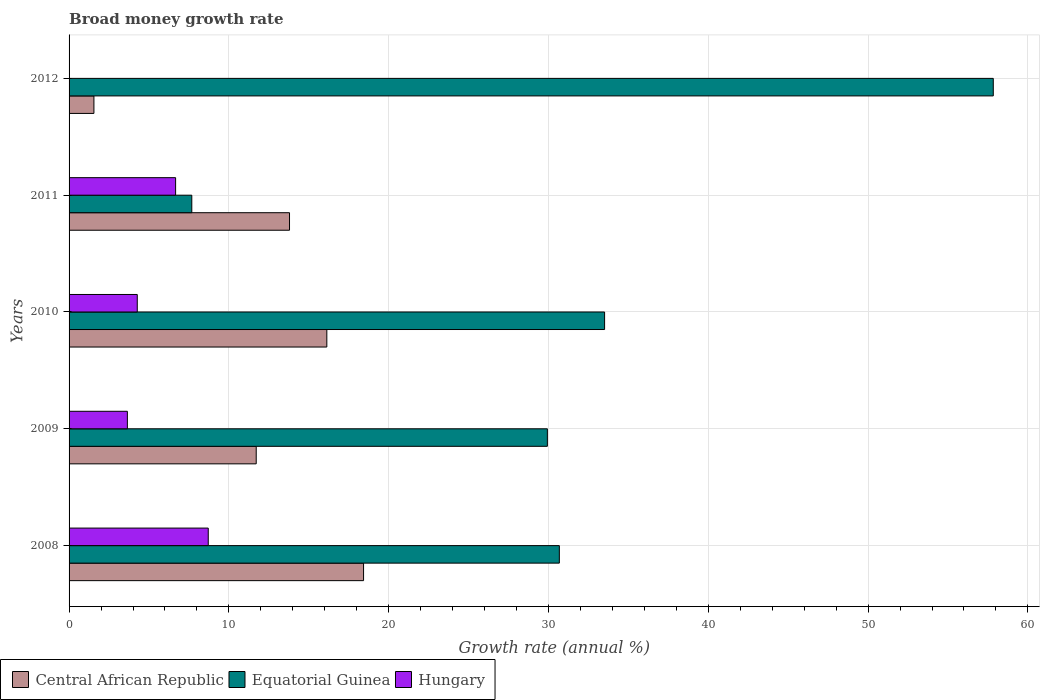In how many cases, is the number of bars for a given year not equal to the number of legend labels?
Offer a very short reply. 1. What is the growth rate in Hungary in 2009?
Provide a short and direct response. 3.65. Across all years, what is the maximum growth rate in Central African Republic?
Provide a short and direct response. 18.43. Across all years, what is the minimum growth rate in Equatorial Guinea?
Your answer should be very brief. 7.68. What is the total growth rate in Hungary in the graph?
Offer a terse response. 23.29. What is the difference between the growth rate in Central African Republic in 2010 and that in 2012?
Make the answer very short. 14.57. What is the difference between the growth rate in Central African Republic in 2010 and the growth rate in Equatorial Guinea in 2009?
Your answer should be very brief. -13.8. What is the average growth rate in Hungary per year?
Keep it short and to the point. 4.66. In the year 2011, what is the difference between the growth rate in Hungary and growth rate in Central African Republic?
Offer a terse response. -7.13. What is the ratio of the growth rate in Hungary in 2008 to that in 2010?
Provide a short and direct response. 2.04. Is the growth rate in Central African Republic in 2010 less than that in 2012?
Your response must be concise. No. What is the difference between the highest and the second highest growth rate in Hungary?
Your answer should be compact. 2.04. What is the difference between the highest and the lowest growth rate in Central African Republic?
Your answer should be compact. 16.87. In how many years, is the growth rate in Central African Republic greater than the average growth rate in Central African Republic taken over all years?
Make the answer very short. 3. Is the sum of the growth rate in Central African Republic in 2008 and 2012 greater than the maximum growth rate in Equatorial Guinea across all years?
Make the answer very short. No. How many bars are there?
Offer a very short reply. 14. Are all the bars in the graph horizontal?
Ensure brevity in your answer.  Yes. Where does the legend appear in the graph?
Provide a succinct answer. Bottom left. How many legend labels are there?
Your response must be concise. 3. What is the title of the graph?
Make the answer very short. Broad money growth rate. What is the label or title of the X-axis?
Your answer should be very brief. Growth rate (annual %). What is the label or title of the Y-axis?
Give a very brief answer. Years. What is the Growth rate (annual %) in Central African Republic in 2008?
Provide a succinct answer. 18.43. What is the Growth rate (annual %) in Equatorial Guinea in 2008?
Your answer should be very brief. 30.68. What is the Growth rate (annual %) of Hungary in 2008?
Provide a short and direct response. 8.71. What is the Growth rate (annual %) in Central African Republic in 2009?
Offer a terse response. 11.71. What is the Growth rate (annual %) of Equatorial Guinea in 2009?
Your answer should be compact. 29.93. What is the Growth rate (annual %) of Hungary in 2009?
Make the answer very short. 3.65. What is the Growth rate (annual %) of Central African Republic in 2010?
Give a very brief answer. 16.13. What is the Growth rate (annual %) in Equatorial Guinea in 2010?
Provide a succinct answer. 33.51. What is the Growth rate (annual %) of Hungary in 2010?
Offer a terse response. 4.27. What is the Growth rate (annual %) in Central African Republic in 2011?
Make the answer very short. 13.79. What is the Growth rate (annual %) of Equatorial Guinea in 2011?
Ensure brevity in your answer.  7.68. What is the Growth rate (annual %) in Hungary in 2011?
Give a very brief answer. 6.67. What is the Growth rate (annual %) in Central African Republic in 2012?
Provide a short and direct response. 1.56. What is the Growth rate (annual %) in Equatorial Guinea in 2012?
Your response must be concise. 57.83. What is the Growth rate (annual %) in Hungary in 2012?
Offer a very short reply. 0. Across all years, what is the maximum Growth rate (annual %) of Central African Republic?
Give a very brief answer. 18.43. Across all years, what is the maximum Growth rate (annual %) of Equatorial Guinea?
Keep it short and to the point. 57.83. Across all years, what is the maximum Growth rate (annual %) of Hungary?
Your answer should be very brief. 8.71. Across all years, what is the minimum Growth rate (annual %) in Central African Republic?
Provide a succinct answer. 1.56. Across all years, what is the minimum Growth rate (annual %) in Equatorial Guinea?
Ensure brevity in your answer.  7.68. Across all years, what is the minimum Growth rate (annual %) of Hungary?
Make the answer very short. 0. What is the total Growth rate (annual %) in Central African Republic in the graph?
Ensure brevity in your answer.  61.62. What is the total Growth rate (annual %) of Equatorial Guinea in the graph?
Your response must be concise. 159.63. What is the total Growth rate (annual %) in Hungary in the graph?
Your answer should be compact. 23.29. What is the difference between the Growth rate (annual %) in Central African Republic in 2008 and that in 2009?
Provide a succinct answer. 6.72. What is the difference between the Growth rate (annual %) in Equatorial Guinea in 2008 and that in 2009?
Offer a very short reply. 0.75. What is the difference between the Growth rate (annual %) in Hungary in 2008 and that in 2009?
Ensure brevity in your answer.  5.06. What is the difference between the Growth rate (annual %) of Central African Republic in 2008 and that in 2010?
Give a very brief answer. 2.3. What is the difference between the Growth rate (annual %) of Equatorial Guinea in 2008 and that in 2010?
Make the answer very short. -2.83. What is the difference between the Growth rate (annual %) in Hungary in 2008 and that in 2010?
Provide a succinct answer. 4.44. What is the difference between the Growth rate (annual %) in Central African Republic in 2008 and that in 2011?
Your answer should be very brief. 4.63. What is the difference between the Growth rate (annual %) in Equatorial Guinea in 2008 and that in 2011?
Offer a very short reply. 23. What is the difference between the Growth rate (annual %) of Hungary in 2008 and that in 2011?
Provide a succinct answer. 2.04. What is the difference between the Growth rate (annual %) in Central African Republic in 2008 and that in 2012?
Ensure brevity in your answer.  16.87. What is the difference between the Growth rate (annual %) of Equatorial Guinea in 2008 and that in 2012?
Your response must be concise. -27.15. What is the difference between the Growth rate (annual %) of Central African Republic in 2009 and that in 2010?
Make the answer very short. -4.42. What is the difference between the Growth rate (annual %) in Equatorial Guinea in 2009 and that in 2010?
Offer a very short reply. -3.58. What is the difference between the Growth rate (annual %) in Hungary in 2009 and that in 2010?
Your answer should be compact. -0.62. What is the difference between the Growth rate (annual %) in Central African Republic in 2009 and that in 2011?
Provide a short and direct response. -2.08. What is the difference between the Growth rate (annual %) in Equatorial Guinea in 2009 and that in 2011?
Your answer should be very brief. 22.25. What is the difference between the Growth rate (annual %) in Hungary in 2009 and that in 2011?
Offer a terse response. -3.02. What is the difference between the Growth rate (annual %) of Central African Republic in 2009 and that in 2012?
Ensure brevity in your answer.  10.16. What is the difference between the Growth rate (annual %) in Equatorial Guinea in 2009 and that in 2012?
Your answer should be very brief. -27.9. What is the difference between the Growth rate (annual %) in Central African Republic in 2010 and that in 2011?
Give a very brief answer. 2.33. What is the difference between the Growth rate (annual %) of Equatorial Guinea in 2010 and that in 2011?
Offer a terse response. 25.83. What is the difference between the Growth rate (annual %) in Hungary in 2010 and that in 2011?
Offer a very short reply. -2.4. What is the difference between the Growth rate (annual %) of Central African Republic in 2010 and that in 2012?
Provide a succinct answer. 14.57. What is the difference between the Growth rate (annual %) in Equatorial Guinea in 2010 and that in 2012?
Keep it short and to the point. -24.32. What is the difference between the Growth rate (annual %) of Central African Republic in 2011 and that in 2012?
Your answer should be very brief. 12.24. What is the difference between the Growth rate (annual %) in Equatorial Guinea in 2011 and that in 2012?
Provide a succinct answer. -50.15. What is the difference between the Growth rate (annual %) of Central African Republic in 2008 and the Growth rate (annual %) of Equatorial Guinea in 2009?
Offer a terse response. -11.5. What is the difference between the Growth rate (annual %) in Central African Republic in 2008 and the Growth rate (annual %) in Hungary in 2009?
Ensure brevity in your answer.  14.78. What is the difference between the Growth rate (annual %) in Equatorial Guinea in 2008 and the Growth rate (annual %) in Hungary in 2009?
Ensure brevity in your answer.  27.03. What is the difference between the Growth rate (annual %) in Central African Republic in 2008 and the Growth rate (annual %) in Equatorial Guinea in 2010?
Offer a very short reply. -15.08. What is the difference between the Growth rate (annual %) of Central African Republic in 2008 and the Growth rate (annual %) of Hungary in 2010?
Provide a succinct answer. 14.16. What is the difference between the Growth rate (annual %) of Equatorial Guinea in 2008 and the Growth rate (annual %) of Hungary in 2010?
Make the answer very short. 26.41. What is the difference between the Growth rate (annual %) in Central African Republic in 2008 and the Growth rate (annual %) in Equatorial Guinea in 2011?
Offer a very short reply. 10.75. What is the difference between the Growth rate (annual %) of Central African Republic in 2008 and the Growth rate (annual %) of Hungary in 2011?
Ensure brevity in your answer.  11.76. What is the difference between the Growth rate (annual %) of Equatorial Guinea in 2008 and the Growth rate (annual %) of Hungary in 2011?
Offer a terse response. 24.01. What is the difference between the Growth rate (annual %) of Central African Republic in 2008 and the Growth rate (annual %) of Equatorial Guinea in 2012?
Offer a very short reply. -39.41. What is the difference between the Growth rate (annual %) in Central African Republic in 2009 and the Growth rate (annual %) in Equatorial Guinea in 2010?
Your answer should be compact. -21.8. What is the difference between the Growth rate (annual %) in Central African Republic in 2009 and the Growth rate (annual %) in Hungary in 2010?
Offer a very short reply. 7.44. What is the difference between the Growth rate (annual %) in Equatorial Guinea in 2009 and the Growth rate (annual %) in Hungary in 2010?
Offer a very short reply. 25.66. What is the difference between the Growth rate (annual %) of Central African Republic in 2009 and the Growth rate (annual %) of Equatorial Guinea in 2011?
Offer a terse response. 4.03. What is the difference between the Growth rate (annual %) of Central African Republic in 2009 and the Growth rate (annual %) of Hungary in 2011?
Ensure brevity in your answer.  5.04. What is the difference between the Growth rate (annual %) in Equatorial Guinea in 2009 and the Growth rate (annual %) in Hungary in 2011?
Ensure brevity in your answer.  23.26. What is the difference between the Growth rate (annual %) of Central African Republic in 2009 and the Growth rate (annual %) of Equatorial Guinea in 2012?
Provide a succinct answer. -46.12. What is the difference between the Growth rate (annual %) of Central African Republic in 2010 and the Growth rate (annual %) of Equatorial Guinea in 2011?
Keep it short and to the point. 8.45. What is the difference between the Growth rate (annual %) of Central African Republic in 2010 and the Growth rate (annual %) of Hungary in 2011?
Provide a short and direct response. 9.46. What is the difference between the Growth rate (annual %) of Equatorial Guinea in 2010 and the Growth rate (annual %) of Hungary in 2011?
Ensure brevity in your answer.  26.84. What is the difference between the Growth rate (annual %) of Central African Republic in 2010 and the Growth rate (annual %) of Equatorial Guinea in 2012?
Your answer should be compact. -41.7. What is the difference between the Growth rate (annual %) in Central African Republic in 2011 and the Growth rate (annual %) in Equatorial Guinea in 2012?
Your response must be concise. -44.04. What is the average Growth rate (annual %) in Central African Republic per year?
Your response must be concise. 12.32. What is the average Growth rate (annual %) of Equatorial Guinea per year?
Your response must be concise. 31.93. What is the average Growth rate (annual %) in Hungary per year?
Give a very brief answer. 4.66. In the year 2008, what is the difference between the Growth rate (annual %) in Central African Republic and Growth rate (annual %) in Equatorial Guinea?
Keep it short and to the point. -12.25. In the year 2008, what is the difference between the Growth rate (annual %) of Central African Republic and Growth rate (annual %) of Hungary?
Provide a short and direct response. 9.72. In the year 2008, what is the difference between the Growth rate (annual %) of Equatorial Guinea and Growth rate (annual %) of Hungary?
Give a very brief answer. 21.97. In the year 2009, what is the difference between the Growth rate (annual %) in Central African Republic and Growth rate (annual %) in Equatorial Guinea?
Provide a short and direct response. -18.22. In the year 2009, what is the difference between the Growth rate (annual %) in Central African Republic and Growth rate (annual %) in Hungary?
Offer a very short reply. 8.06. In the year 2009, what is the difference between the Growth rate (annual %) in Equatorial Guinea and Growth rate (annual %) in Hungary?
Provide a short and direct response. 26.28. In the year 2010, what is the difference between the Growth rate (annual %) in Central African Republic and Growth rate (annual %) in Equatorial Guinea?
Your response must be concise. -17.38. In the year 2010, what is the difference between the Growth rate (annual %) of Central African Republic and Growth rate (annual %) of Hungary?
Keep it short and to the point. 11.86. In the year 2010, what is the difference between the Growth rate (annual %) of Equatorial Guinea and Growth rate (annual %) of Hungary?
Make the answer very short. 29.24. In the year 2011, what is the difference between the Growth rate (annual %) of Central African Republic and Growth rate (annual %) of Equatorial Guinea?
Provide a short and direct response. 6.11. In the year 2011, what is the difference between the Growth rate (annual %) in Central African Republic and Growth rate (annual %) in Hungary?
Your answer should be compact. 7.13. In the year 2011, what is the difference between the Growth rate (annual %) in Equatorial Guinea and Growth rate (annual %) in Hungary?
Ensure brevity in your answer.  1.01. In the year 2012, what is the difference between the Growth rate (annual %) of Central African Republic and Growth rate (annual %) of Equatorial Guinea?
Offer a terse response. -56.28. What is the ratio of the Growth rate (annual %) in Central African Republic in 2008 to that in 2009?
Provide a short and direct response. 1.57. What is the ratio of the Growth rate (annual %) in Hungary in 2008 to that in 2009?
Offer a very short reply. 2.39. What is the ratio of the Growth rate (annual %) of Central African Republic in 2008 to that in 2010?
Your answer should be compact. 1.14. What is the ratio of the Growth rate (annual %) in Equatorial Guinea in 2008 to that in 2010?
Keep it short and to the point. 0.92. What is the ratio of the Growth rate (annual %) of Hungary in 2008 to that in 2010?
Your response must be concise. 2.04. What is the ratio of the Growth rate (annual %) of Central African Republic in 2008 to that in 2011?
Give a very brief answer. 1.34. What is the ratio of the Growth rate (annual %) in Equatorial Guinea in 2008 to that in 2011?
Offer a very short reply. 3.99. What is the ratio of the Growth rate (annual %) in Hungary in 2008 to that in 2011?
Your answer should be compact. 1.31. What is the ratio of the Growth rate (annual %) of Central African Republic in 2008 to that in 2012?
Offer a very short reply. 11.85. What is the ratio of the Growth rate (annual %) in Equatorial Guinea in 2008 to that in 2012?
Provide a short and direct response. 0.53. What is the ratio of the Growth rate (annual %) in Central African Republic in 2009 to that in 2010?
Keep it short and to the point. 0.73. What is the ratio of the Growth rate (annual %) of Equatorial Guinea in 2009 to that in 2010?
Give a very brief answer. 0.89. What is the ratio of the Growth rate (annual %) in Hungary in 2009 to that in 2010?
Your answer should be compact. 0.85. What is the ratio of the Growth rate (annual %) in Central African Republic in 2009 to that in 2011?
Ensure brevity in your answer.  0.85. What is the ratio of the Growth rate (annual %) of Equatorial Guinea in 2009 to that in 2011?
Give a very brief answer. 3.9. What is the ratio of the Growth rate (annual %) in Hungary in 2009 to that in 2011?
Ensure brevity in your answer.  0.55. What is the ratio of the Growth rate (annual %) of Central African Republic in 2009 to that in 2012?
Give a very brief answer. 7.53. What is the ratio of the Growth rate (annual %) of Equatorial Guinea in 2009 to that in 2012?
Ensure brevity in your answer.  0.52. What is the ratio of the Growth rate (annual %) in Central African Republic in 2010 to that in 2011?
Your answer should be very brief. 1.17. What is the ratio of the Growth rate (annual %) in Equatorial Guinea in 2010 to that in 2011?
Give a very brief answer. 4.36. What is the ratio of the Growth rate (annual %) in Hungary in 2010 to that in 2011?
Offer a very short reply. 0.64. What is the ratio of the Growth rate (annual %) in Central African Republic in 2010 to that in 2012?
Ensure brevity in your answer.  10.37. What is the ratio of the Growth rate (annual %) in Equatorial Guinea in 2010 to that in 2012?
Provide a succinct answer. 0.58. What is the ratio of the Growth rate (annual %) of Central African Republic in 2011 to that in 2012?
Provide a short and direct response. 8.87. What is the ratio of the Growth rate (annual %) in Equatorial Guinea in 2011 to that in 2012?
Give a very brief answer. 0.13. What is the difference between the highest and the second highest Growth rate (annual %) in Central African Republic?
Offer a terse response. 2.3. What is the difference between the highest and the second highest Growth rate (annual %) of Equatorial Guinea?
Offer a terse response. 24.32. What is the difference between the highest and the second highest Growth rate (annual %) of Hungary?
Offer a terse response. 2.04. What is the difference between the highest and the lowest Growth rate (annual %) in Central African Republic?
Give a very brief answer. 16.87. What is the difference between the highest and the lowest Growth rate (annual %) in Equatorial Guinea?
Provide a short and direct response. 50.15. What is the difference between the highest and the lowest Growth rate (annual %) in Hungary?
Offer a terse response. 8.71. 